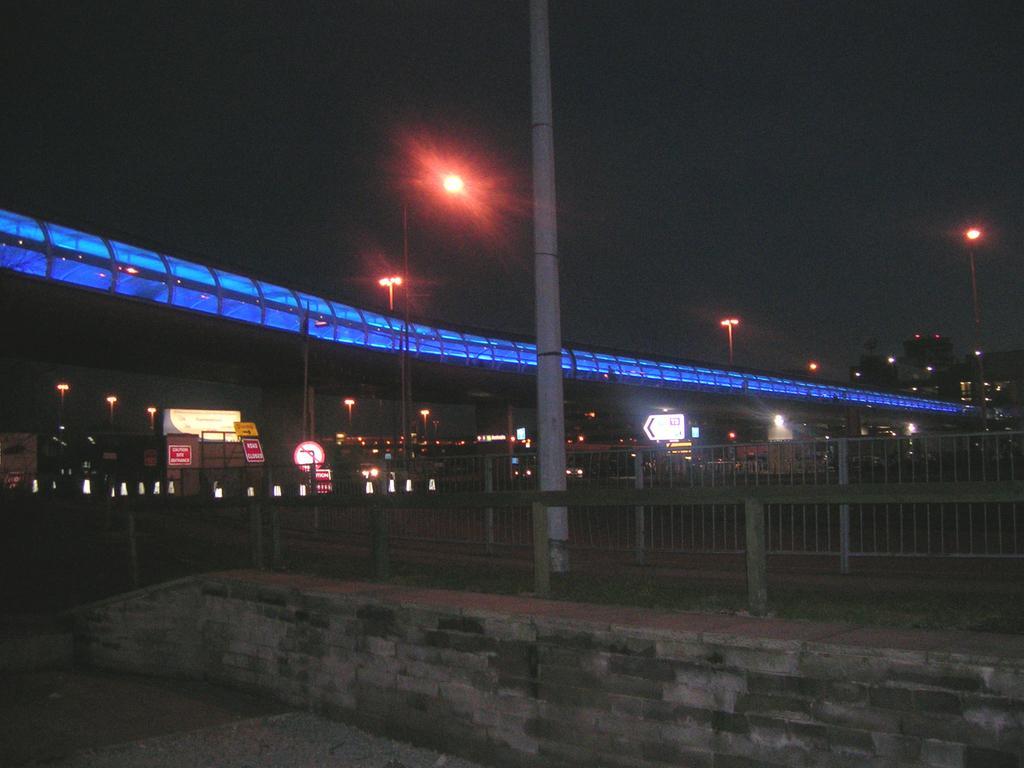Can you describe this image briefly? At the bottom of the image we can see fencing. Behind the fencing we can see some poles, banners, lights, sign boards and bridge. Behind the we can see some buildings. 